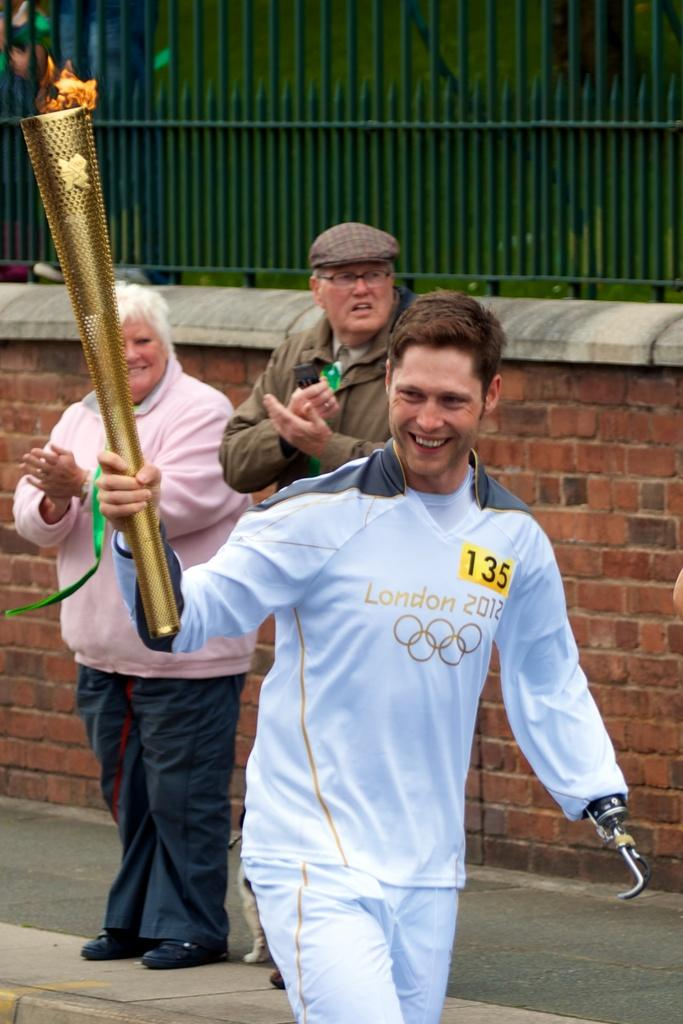<image>
Relay a brief, clear account of the picture shown. A man carrying the torch at the London Olympics has the number 135 on his shirt. 